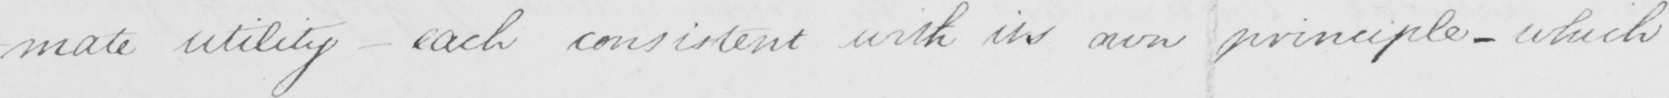Can you read and transcribe this handwriting? -mate utility  _  each consistent with its own principle  _  which 